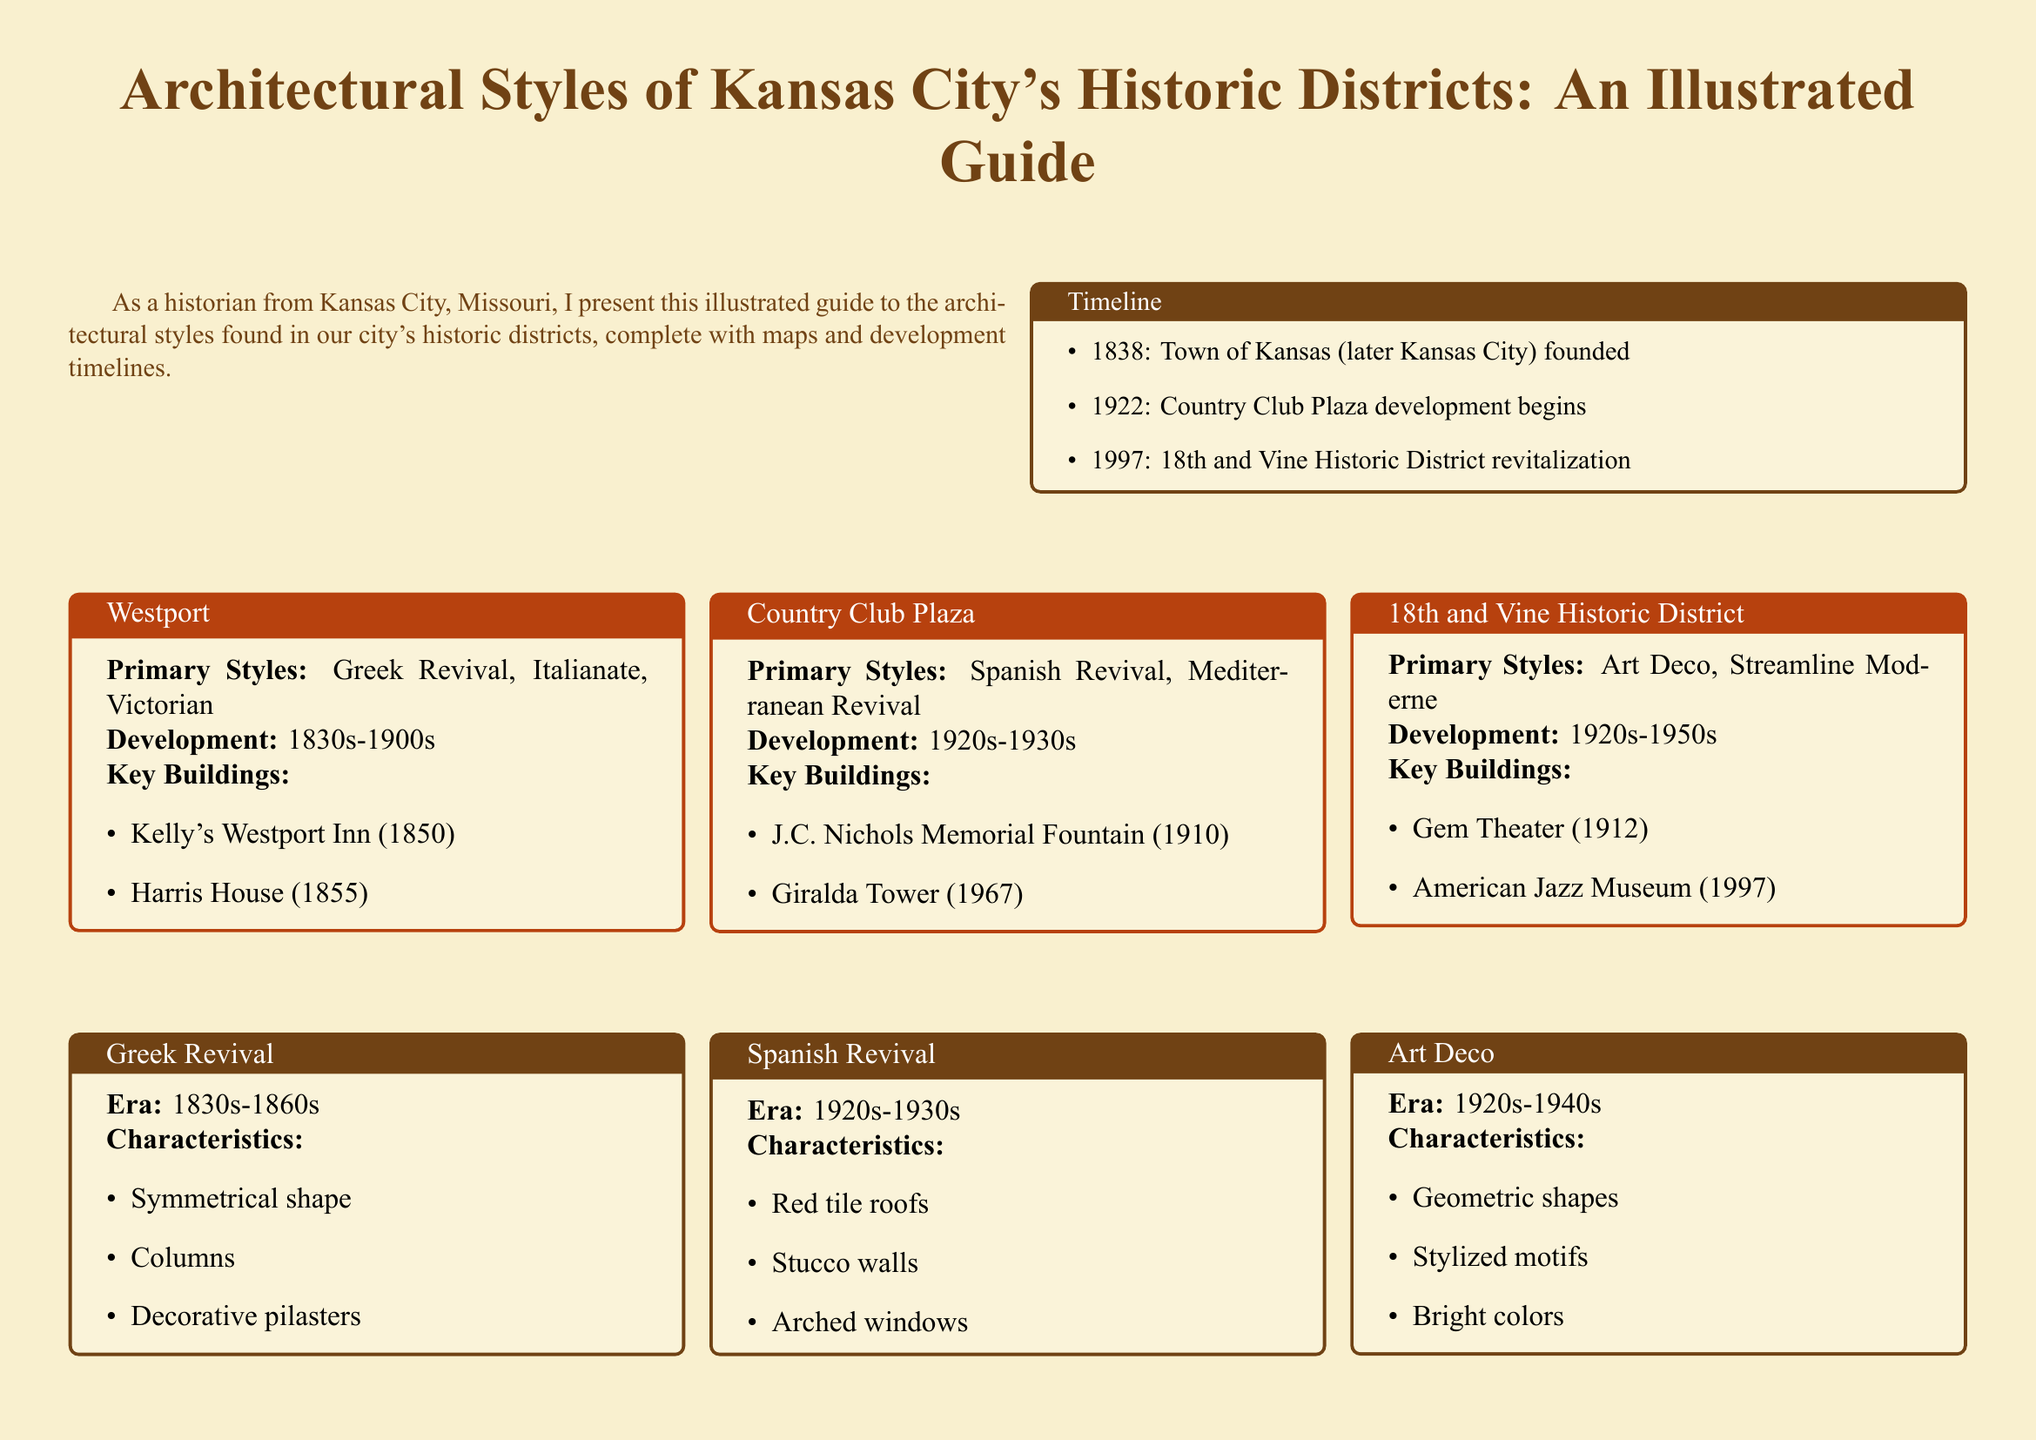What year was the Town of Kansas founded? The timeline in the document states that the town was founded in 1838.
Answer: 1838 What are the primary architectural styles in Westport? The document lists Greek Revival, Italianate, and Victorian as the primary styles in Westport.
Answer: Greek Revival, Italianate, Victorian Which building in Country Club Plaza was completed in 1910? The key buildings section mentions the J.C. Nichols Memorial Fountain was completed in 1910.
Answer: J.C. Nichols Memorial Fountain During which era was the Art Deco style predominant? The characteristics box for Art Deco specifies the era as 1920s to 1940s.
Answer: 1920s-1940s What are the key characteristics of Spanish Revival architecture? The document lists red tile roofs, stucco walls, and arched windows as characteristics of Spanish Revival.
Answer: Red tile roofs, stucco walls, arched windows What was the primary style of the 18th and Vine Historic District? The document indicates that the primary styles of the 18th and Vine Historic District are Art Deco and Streamline Moderne.
Answer: Art Deco, Streamline Moderne How many historic districts are highlighted in the map description? The description mentions three districts: Westport, Country Club Plaza, and 18th and Vine Historic District.
Answer: Three What significant development began in 1997? The timeline mentions the revitalization of the 18th and Vine Historic District as starting in 1997.
Answer: 18th and Vine Historic District revitalization 